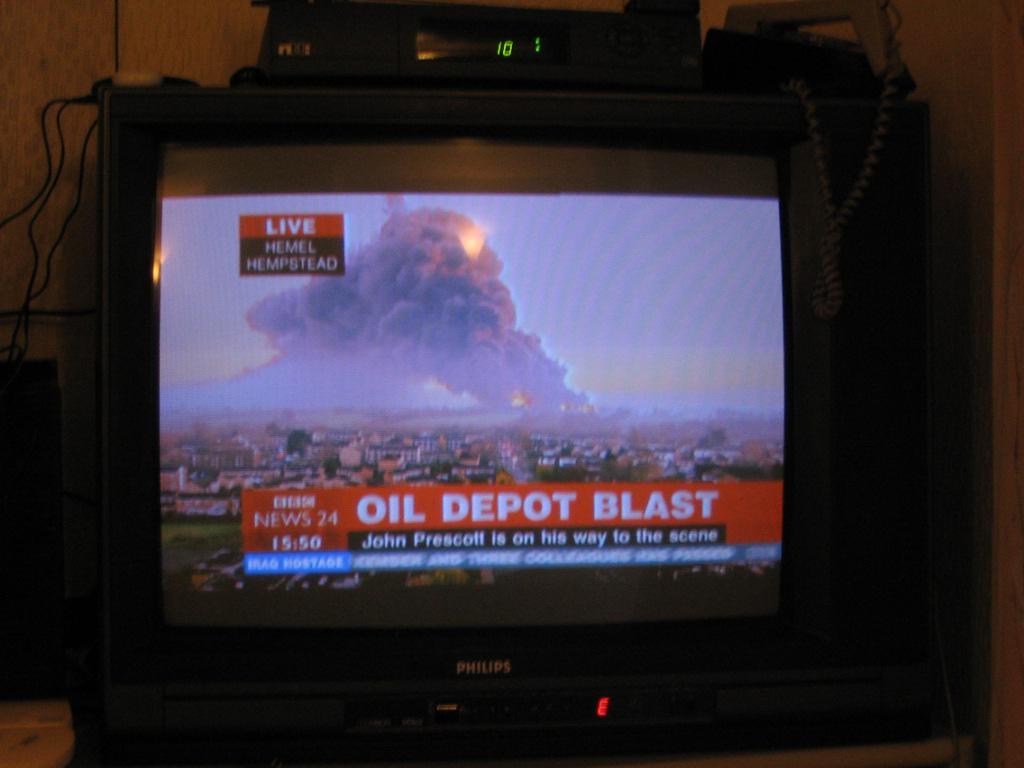What is the time in the photo?
Your response must be concise. 15:50. What is the news about?
Offer a terse response. Oil depot blast. 